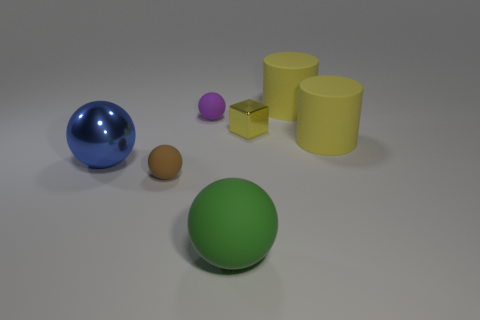Subtract all matte spheres. How many spheres are left? 1 Subtract all purple spheres. How many spheres are left? 3 Subtract 1 spheres. How many spheres are left? 3 Add 2 small objects. How many objects exist? 9 Subtract all cubes. How many objects are left? 6 Subtract 0 gray spheres. How many objects are left? 7 Subtract all blue spheres. Subtract all gray cylinders. How many spheres are left? 3 Subtract all small red shiny cylinders. Subtract all large spheres. How many objects are left? 5 Add 1 tiny metal blocks. How many tiny metal blocks are left? 2 Add 4 small spheres. How many small spheres exist? 6 